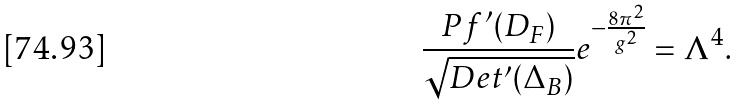<formula> <loc_0><loc_0><loc_500><loc_500>\frac { P f ^ { \prime } ( D _ { F } ) } { \sqrt { D e t ^ { \prime } ( \Delta _ { B } ) } } e ^ { - \frac { 8 \pi ^ { 2 } } { g ^ { 2 } } } = \Lambda ^ { 4 } .</formula> 